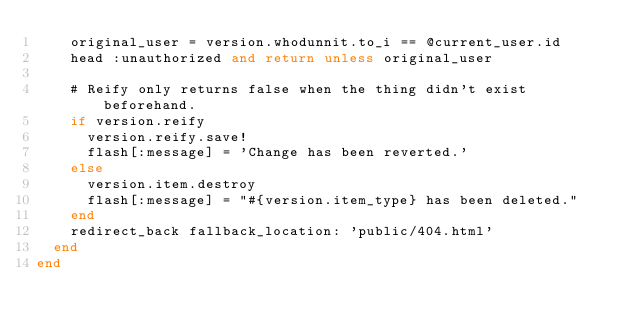Convert code to text. <code><loc_0><loc_0><loc_500><loc_500><_Ruby_>    original_user = version.whodunnit.to_i == @current_user.id
    head :unauthorized and return unless original_user

    # Reify only returns false when the thing didn't exist beforehand.
    if version.reify
      version.reify.save!
      flash[:message] = 'Change has been reverted.'
    else
      version.item.destroy
      flash[:message] = "#{version.item_type} has been deleted."
    end
    redirect_back fallback_location: 'public/404.html'
  end
end
</code> 